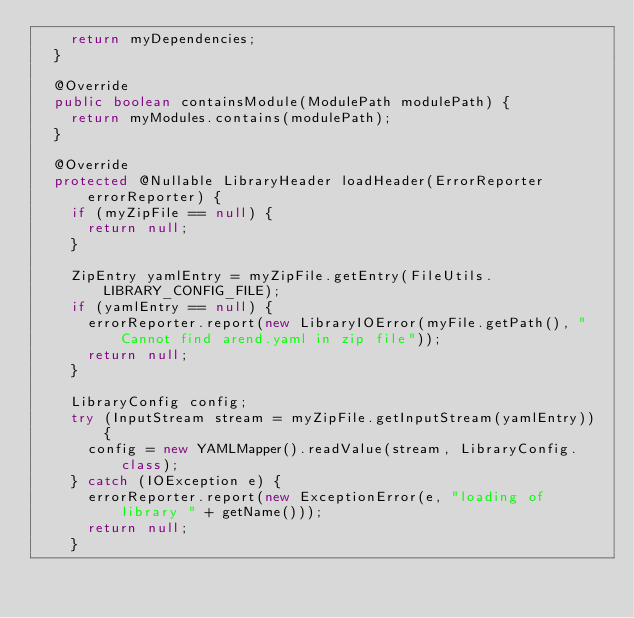Convert code to text. <code><loc_0><loc_0><loc_500><loc_500><_Java_>    return myDependencies;
  }

  @Override
  public boolean containsModule(ModulePath modulePath) {
    return myModules.contains(modulePath);
  }

  @Override
  protected @Nullable LibraryHeader loadHeader(ErrorReporter errorReporter) {
    if (myZipFile == null) {
      return null;
    }

    ZipEntry yamlEntry = myZipFile.getEntry(FileUtils.LIBRARY_CONFIG_FILE);
    if (yamlEntry == null) {
      errorReporter.report(new LibraryIOError(myFile.getPath(), "Cannot find arend.yaml in zip file"));
      return null;
    }

    LibraryConfig config;
    try (InputStream stream = myZipFile.getInputStream(yamlEntry)) {
      config = new YAMLMapper().readValue(stream, LibraryConfig.class);
    } catch (IOException e) {
      errorReporter.report(new ExceptionError(e, "loading of library " + getName()));
      return null;
    }
</code> 